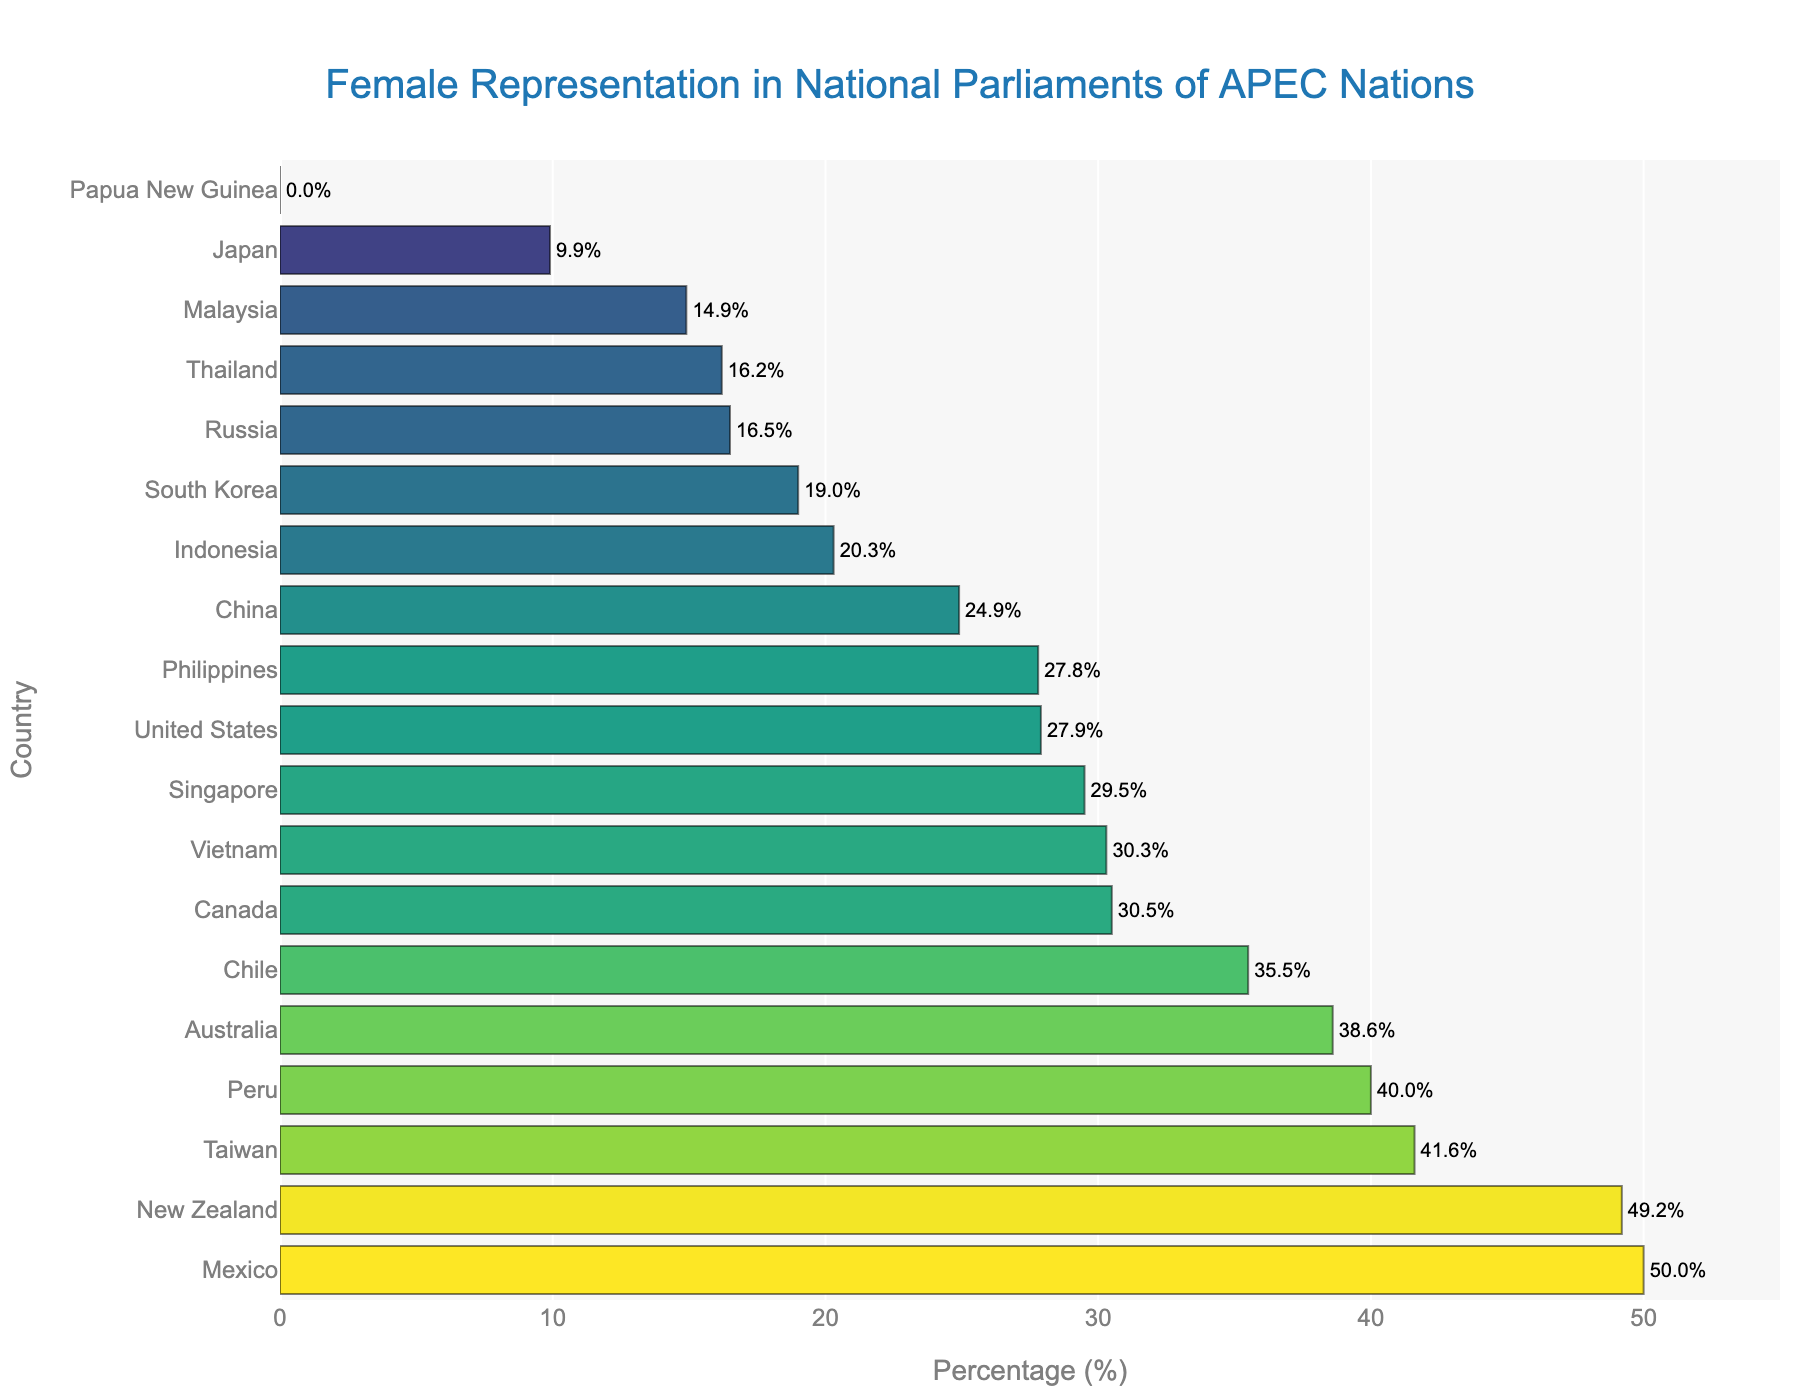Which country has the highest female representation in national parliaments? By looking at the bar chart, the country with the longest bar on the right side represents the highest female representation.
Answer: Mexico What is the female representation percentage in Japan? Find the bar corresponding to Japan on the y-axis, then read the value on the x-axis adjacent to that bar.
Answer: 9.9% Which countries have female representation below 20%? Identify the bars that extend less than 20% on the x-axis and find the corresponding country names on the y-axis.
Answer: Japan, Malaysia, Papua New Guinea, Russia, South Korea, Thailand How much higher is New Zealand's female representation compared to the United States? Find the female representation percentages for New Zealand and the United States and subtract the smaller value from the larger one: 49.2% - 27.9%
Answer: 21.3% Which country has zero female representation in its national parliament? Look for the shortest bar, which represents 0% female representation, and identify the corresponding country.
Answer: Papua New Guinea What is the average female representation in national parliaments among the APEC nations? Sum all the female representation percentages and divide by the number of countries: (38.6 + 30.5 + 35.5 + 24.9 + 20.3 + 9.9 + 14.9 + 50.0 + 49.2 + 0.0 + 40.0 + 27.8 + 16.5 + 29.5 + 19.0 + 41.6 + 16.2 + 27.9 + 30.3) / 19
Answer: 27.1% What is the difference in female representation between Peru and China? Subtract the percentage of female representation in China from that in Peru: 40.0% - 24.9%
Answer: 15.1% Which countries have female representation percentages between 30% and 40%? Identify the bars that fall between 30% and 40% on the x-axis and find the corresponding country names on the y-axis.
Answer: Australia, Canada, Chile, Vietnam By how much does the female representation in Mexico exceed that in Indonesia? Subtract the percentage of female representation in Indonesia from that in Mexico: 50.0% - 20.3%
Answer: 29.7% 